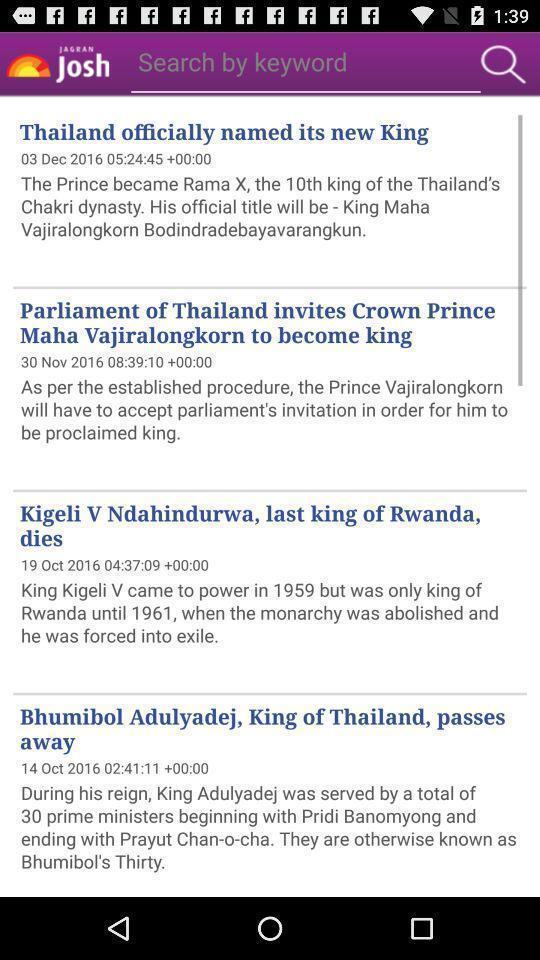Summarize the main components in this picture. Search page for finding the current affairs for exams. 